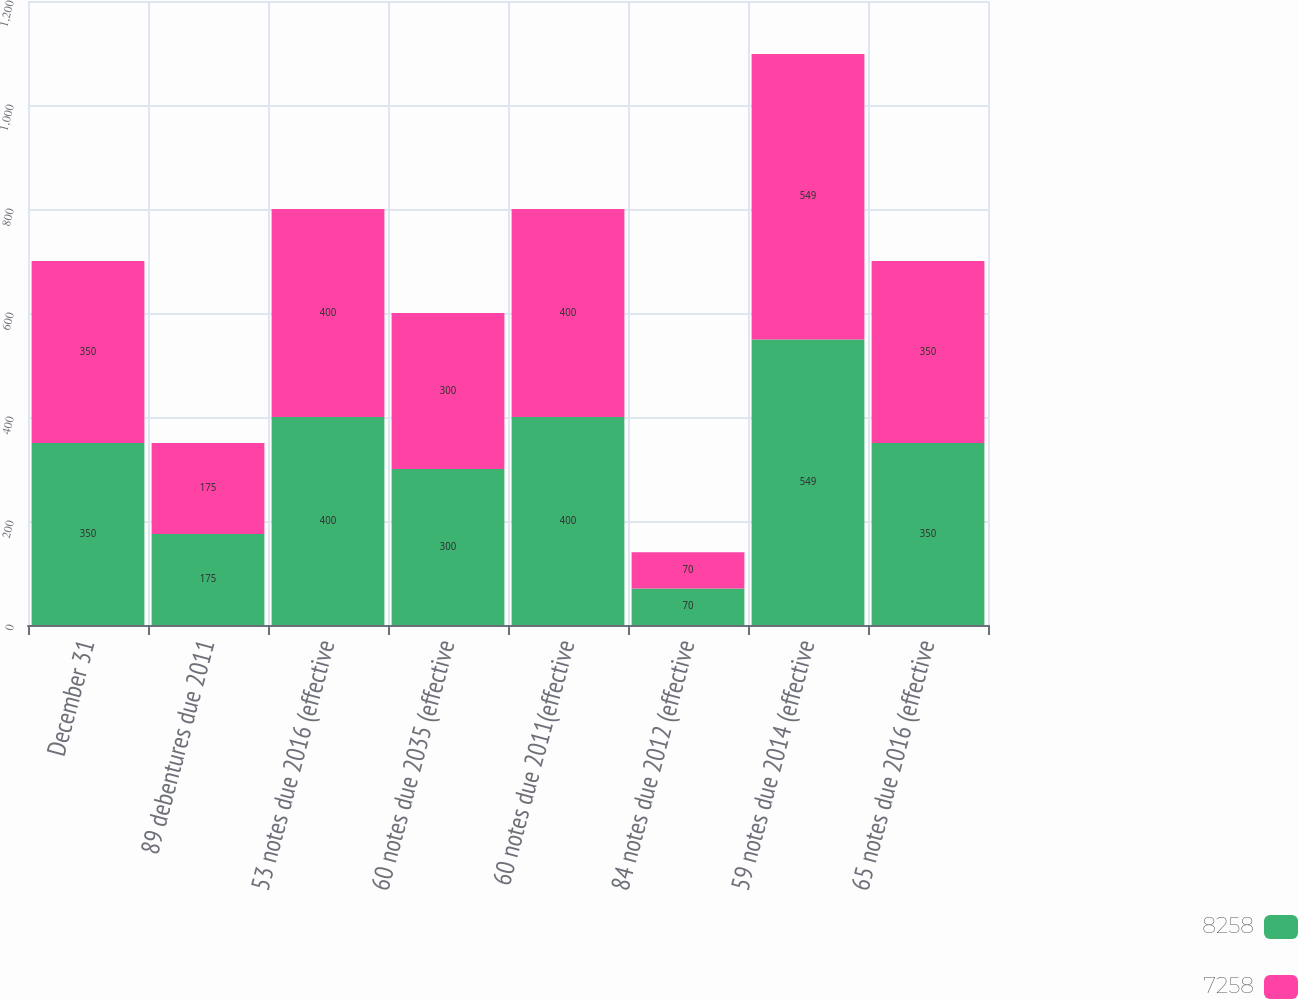<chart> <loc_0><loc_0><loc_500><loc_500><stacked_bar_chart><ecel><fcel>December 31<fcel>89 debentures due 2011<fcel>53 notes due 2016 (effective<fcel>60 notes due 2035 (effective<fcel>60 notes due 2011(effective<fcel>84 notes due 2012 (effective<fcel>59 notes due 2014 (effective<fcel>65 notes due 2016 (effective<nl><fcel>8258<fcel>350<fcel>175<fcel>400<fcel>300<fcel>400<fcel>70<fcel>549<fcel>350<nl><fcel>7258<fcel>350<fcel>175<fcel>400<fcel>300<fcel>400<fcel>70<fcel>549<fcel>350<nl></chart> 